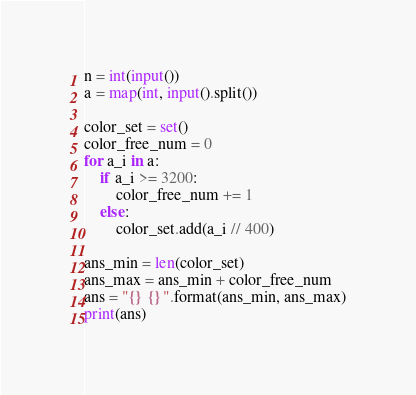<code> <loc_0><loc_0><loc_500><loc_500><_Python_>n = int(input())
a = map(int, input().split())

color_set = set()
color_free_num = 0
for a_i in a:
    if a_i >= 3200:
        color_free_num += 1
    else:
        color_set.add(a_i // 400)

ans_min = len(color_set)
ans_max = ans_min + color_free_num
ans = "{} {}".format(ans_min, ans_max)
print(ans)</code> 